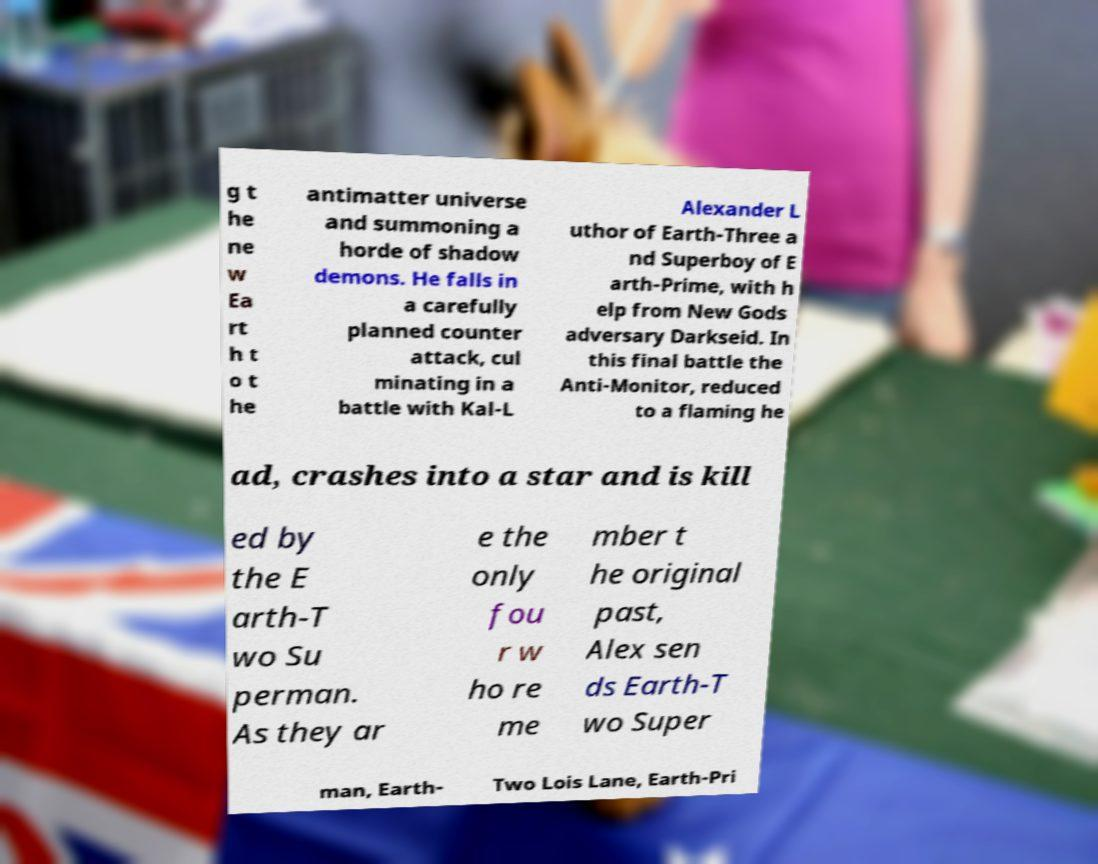For documentation purposes, I need the text within this image transcribed. Could you provide that? g t he ne w Ea rt h t o t he antimatter universe and summoning a horde of shadow demons. He falls in a carefully planned counter attack, cul minating in a battle with Kal-L Alexander L uthor of Earth-Three a nd Superboy of E arth-Prime, with h elp from New Gods adversary Darkseid. In this final battle the Anti-Monitor, reduced to a flaming he ad, crashes into a star and is kill ed by the E arth-T wo Su perman. As they ar e the only fou r w ho re me mber t he original past, Alex sen ds Earth-T wo Super man, Earth- Two Lois Lane, Earth-Pri 